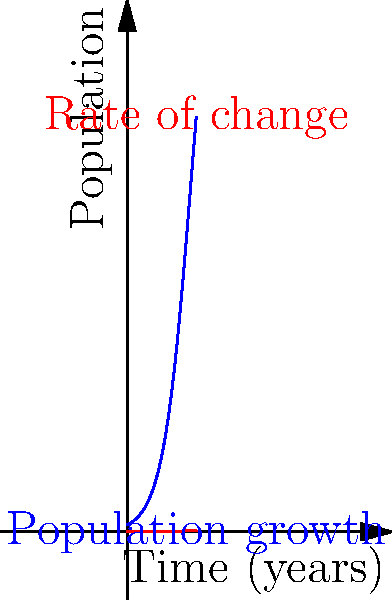The blue curve represents a population growth model for a species of fish in a new ecosystem, while the red curve shows the rate of change of the population. After how many years does the rate of population growth reach its maximum? To find when the rate of population growth reaches its maximum, we need to analyze the red curve, which represents the rate of change.

Steps:
1. Observe that the red curve (rate of change) increases initially, reaches a peak, and then decreases.
2. The maximum point of the red curve occurs at its peak.
3. Estimate the x-coordinate (time) at the peak of the red curve.
4. From the graph, we can see that the peak of the red curve occurs at approximately 4.6 years.

The rate of population growth is highest when the population is growing most rapidly, which happens at the steepest point of the blue curve (population). This point corresponds to the inflection point of the blue curve, which aligns with the peak of the red curve (rate of change).
Answer: $4.6$ years 